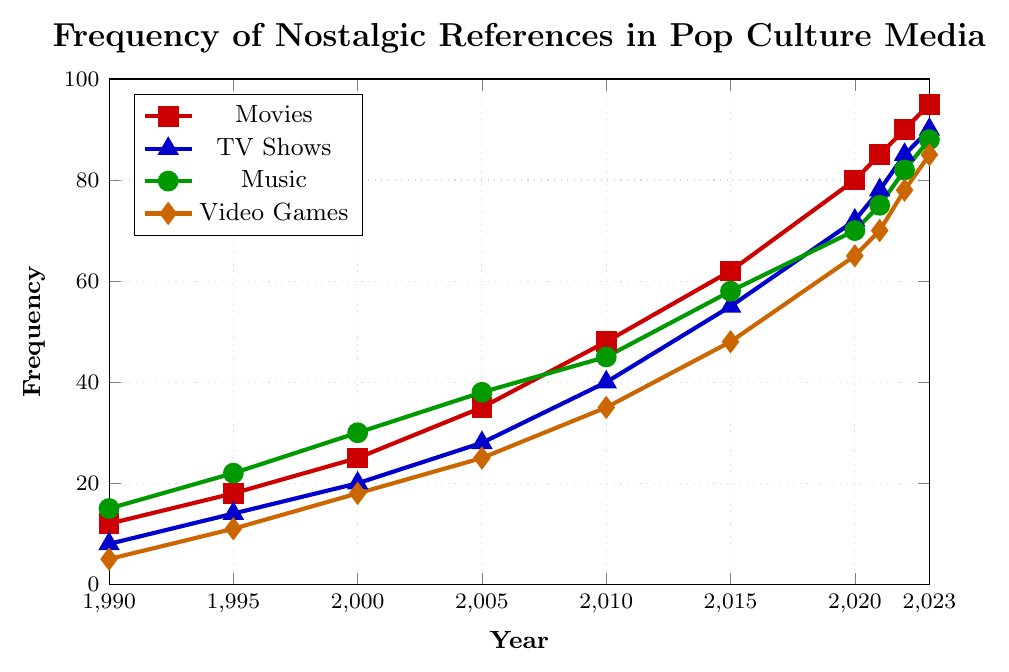What is the frequency of nostalgic references in movies in 2015? Look at the point on the red line (Movies) corresponding to the year 2015. The y-value at this point represents the frequency.
Answer: 62 How much did the frequency of nostalgic references in TV shows increase from 1995 to 2010? Find the y-values for TV shows (blue line) at 1995 and 2010 and subtract the 1995 value from the 2010 value: 40 - 14 = 26.
Answer: 26 Which category had the highest frequency of nostalgic references in 2023? Compare the y-values for all categories (red, blue, green, and orange lines) at 2023. The highest y-value is for Movies (red line), which is 95.
Answer: Movies What is the sum of nostalgic references in music from 1995 to 2005? Add the y-values for Music (green line) at 1995, 2000, and 2005: 22 + 30 + 38 = 90.
Answer: 90 In which year did video games first reach a frequency of 70? Locate the point on the orange line (Video Games) where the y-value first reaches 70. This occurs in 2021.
Answer: 2021 By how much has the frequency of nostalgic references in movies increased from 1990 to 2023? Find the y-values for Movies (red line) at 1990 and 2023 and subtract the 1990 value from the 2023 value: 95 - 12 = 83.
Answer: 83 How does the frequency of nostalgic references in TV shows in 2020 compare to that in movies in the same year? Compare the y-values for TV shows (blue line) and movies (red line) at 2020. TV shows have a frequency of 72, while movies have a frequency of 80.
Answer: Movies are higher What is the average frequency of nostalgic references in video games from 2000 to 2010? Add the y-values for Video Games (orange line) at 2000, 2005, and 2010, then divide by the number of data points: (18 + 25 + 35) / 3 = 26.
Answer: 26 Which year had the smallest increase in nostalgic references in music compared to the previous year? Calculate the differences in y-values for Music (green line) between consecutive years and identify the smallest increase. The smallest increase is from 2021 to 2022: 82 - 75 = 7.
Answer: 2022 What is the difference in the frequency of nostalgic references between TV shows and video games in 2023? Find the y-values for TV shows (blue line) and video games (orange line) at 2023 and subtract the video games value from the TV shows value: 90 - 85 = 5.
Answer: 5 